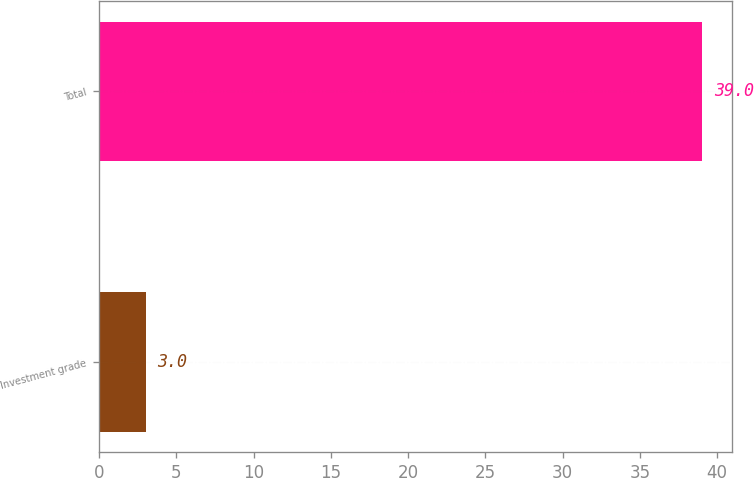Convert chart to OTSL. <chart><loc_0><loc_0><loc_500><loc_500><bar_chart><fcel>Investment grade<fcel>Total<nl><fcel>3<fcel>39<nl></chart> 